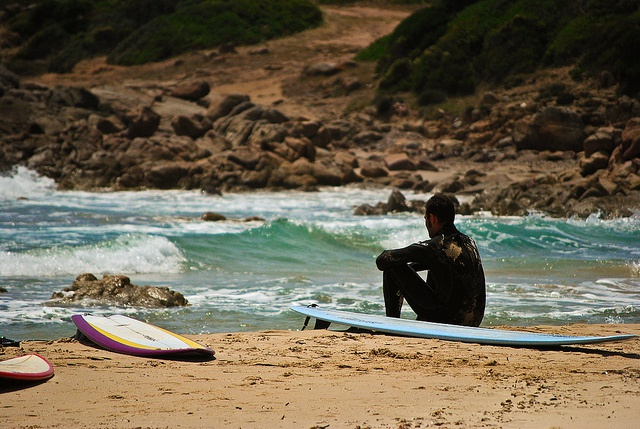Describe the objects in this image and their specific colors. I can see people in black, darkgray, lightgray, and gray tones, surfboard in black, lightblue, lightgray, gray, and darkgray tones, surfboard in black, lightgray, purple, and gold tones, and surfboard in black, tan, maroon, and brown tones in this image. 